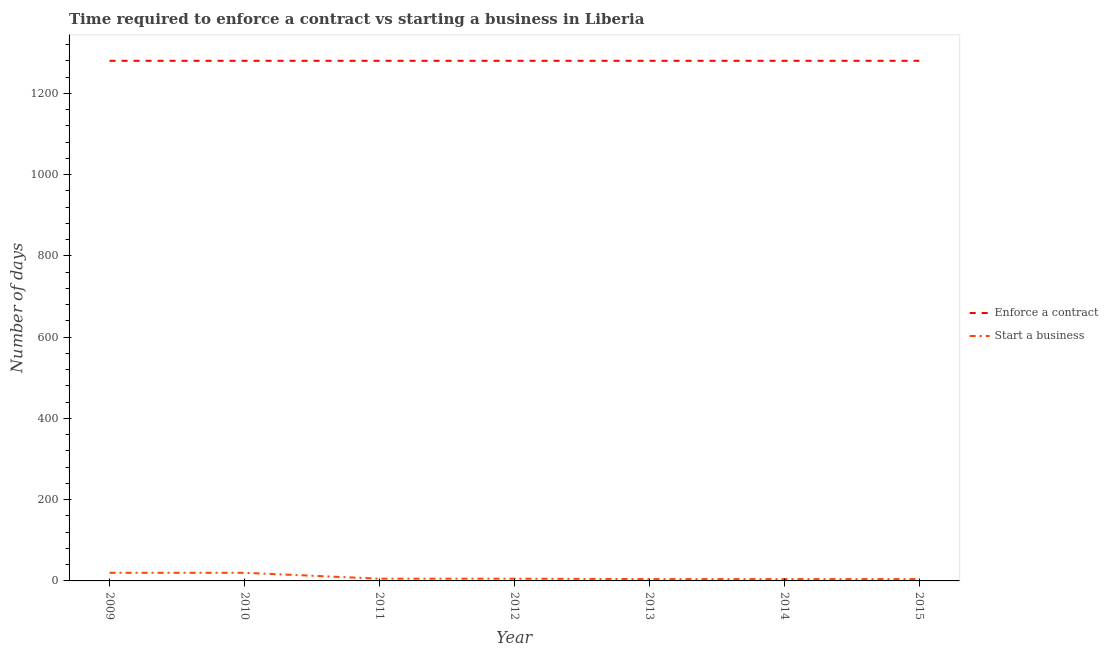How many different coloured lines are there?
Keep it short and to the point. 2. Does the line corresponding to number of days to start a business intersect with the line corresponding to number of days to enforece a contract?
Ensure brevity in your answer.  No. Across all years, what is the maximum number of days to enforece a contract?
Offer a terse response. 1280. What is the total number of days to start a business in the graph?
Provide a short and direct response. 64.5. What is the difference between the number of days to enforece a contract in 2015 and the number of days to start a business in 2012?
Ensure brevity in your answer.  1274.5. What is the average number of days to enforece a contract per year?
Ensure brevity in your answer.  1280. In the year 2010, what is the difference between the number of days to enforece a contract and number of days to start a business?
Offer a terse response. 1260. In how many years, is the number of days to enforece a contract greater than 200 days?
Ensure brevity in your answer.  7. Is the difference between the number of days to enforece a contract in 2010 and 2014 greater than the difference between the number of days to start a business in 2010 and 2014?
Your answer should be very brief. No. What is the difference between the highest and the second highest number of days to enforece a contract?
Provide a succinct answer. 0. In how many years, is the number of days to enforece a contract greater than the average number of days to enforece a contract taken over all years?
Your response must be concise. 0. Is the sum of the number of days to start a business in 2009 and 2012 greater than the maximum number of days to enforece a contract across all years?
Your answer should be compact. No. Does the number of days to start a business monotonically increase over the years?
Provide a succinct answer. No. How many lines are there?
Your answer should be compact. 2. What is the difference between two consecutive major ticks on the Y-axis?
Your answer should be very brief. 200. Does the graph contain any zero values?
Provide a succinct answer. No. Where does the legend appear in the graph?
Offer a terse response. Center right. What is the title of the graph?
Provide a short and direct response. Time required to enforce a contract vs starting a business in Liberia. What is the label or title of the Y-axis?
Provide a short and direct response. Number of days. What is the Number of days in Enforce a contract in 2009?
Give a very brief answer. 1280. What is the Number of days of Enforce a contract in 2010?
Provide a short and direct response. 1280. What is the Number of days of Start a business in 2010?
Provide a succinct answer. 20. What is the Number of days of Enforce a contract in 2011?
Provide a succinct answer. 1280. What is the Number of days in Start a business in 2011?
Offer a very short reply. 5.5. What is the Number of days in Enforce a contract in 2012?
Offer a terse response. 1280. What is the Number of days of Enforce a contract in 2013?
Provide a succinct answer. 1280. What is the Number of days in Enforce a contract in 2014?
Make the answer very short. 1280. What is the Number of days of Enforce a contract in 2015?
Your response must be concise. 1280. Across all years, what is the maximum Number of days of Enforce a contract?
Provide a short and direct response. 1280. Across all years, what is the maximum Number of days of Start a business?
Your answer should be compact. 20. Across all years, what is the minimum Number of days of Enforce a contract?
Your answer should be very brief. 1280. What is the total Number of days of Enforce a contract in the graph?
Your answer should be compact. 8960. What is the total Number of days of Start a business in the graph?
Provide a short and direct response. 64.5. What is the difference between the Number of days in Start a business in 2009 and that in 2010?
Your answer should be compact. 0. What is the difference between the Number of days of Start a business in 2009 and that in 2011?
Keep it short and to the point. 14.5. What is the difference between the Number of days of Enforce a contract in 2009 and that in 2013?
Keep it short and to the point. 0. What is the difference between the Number of days in Start a business in 2009 and that in 2013?
Provide a succinct answer. 15.5. What is the difference between the Number of days of Enforce a contract in 2009 and that in 2014?
Offer a terse response. 0. What is the difference between the Number of days of Start a business in 2009 and that in 2014?
Provide a short and direct response. 15.5. What is the difference between the Number of days of Start a business in 2009 and that in 2015?
Give a very brief answer. 15.5. What is the difference between the Number of days of Enforce a contract in 2010 and that in 2012?
Your response must be concise. 0. What is the difference between the Number of days of Enforce a contract in 2010 and that in 2013?
Ensure brevity in your answer.  0. What is the difference between the Number of days in Start a business in 2010 and that in 2014?
Offer a very short reply. 15.5. What is the difference between the Number of days of Start a business in 2010 and that in 2015?
Your response must be concise. 15.5. What is the difference between the Number of days in Enforce a contract in 2011 and that in 2012?
Provide a short and direct response. 0. What is the difference between the Number of days of Enforce a contract in 2011 and that in 2013?
Ensure brevity in your answer.  0. What is the difference between the Number of days of Enforce a contract in 2011 and that in 2014?
Provide a short and direct response. 0. What is the difference between the Number of days of Start a business in 2011 and that in 2014?
Your answer should be very brief. 1. What is the difference between the Number of days of Enforce a contract in 2011 and that in 2015?
Keep it short and to the point. 0. What is the difference between the Number of days in Start a business in 2011 and that in 2015?
Your answer should be very brief. 1. What is the difference between the Number of days of Enforce a contract in 2012 and that in 2013?
Your response must be concise. 0. What is the difference between the Number of days in Start a business in 2012 and that in 2013?
Offer a terse response. 1. What is the difference between the Number of days in Enforce a contract in 2012 and that in 2014?
Give a very brief answer. 0. What is the difference between the Number of days of Start a business in 2012 and that in 2014?
Your answer should be compact. 1. What is the difference between the Number of days in Enforce a contract in 2013 and that in 2014?
Your answer should be compact. 0. What is the difference between the Number of days in Start a business in 2013 and that in 2014?
Your answer should be very brief. 0. What is the difference between the Number of days of Enforce a contract in 2013 and that in 2015?
Give a very brief answer. 0. What is the difference between the Number of days in Start a business in 2013 and that in 2015?
Your response must be concise. 0. What is the difference between the Number of days of Enforce a contract in 2014 and that in 2015?
Your answer should be very brief. 0. What is the difference between the Number of days in Enforce a contract in 2009 and the Number of days in Start a business in 2010?
Your answer should be compact. 1260. What is the difference between the Number of days of Enforce a contract in 2009 and the Number of days of Start a business in 2011?
Make the answer very short. 1274.5. What is the difference between the Number of days in Enforce a contract in 2009 and the Number of days in Start a business in 2012?
Keep it short and to the point. 1274.5. What is the difference between the Number of days of Enforce a contract in 2009 and the Number of days of Start a business in 2013?
Your answer should be very brief. 1275.5. What is the difference between the Number of days of Enforce a contract in 2009 and the Number of days of Start a business in 2014?
Offer a terse response. 1275.5. What is the difference between the Number of days of Enforce a contract in 2009 and the Number of days of Start a business in 2015?
Your answer should be compact. 1275.5. What is the difference between the Number of days in Enforce a contract in 2010 and the Number of days in Start a business in 2011?
Keep it short and to the point. 1274.5. What is the difference between the Number of days of Enforce a contract in 2010 and the Number of days of Start a business in 2012?
Make the answer very short. 1274.5. What is the difference between the Number of days of Enforce a contract in 2010 and the Number of days of Start a business in 2013?
Give a very brief answer. 1275.5. What is the difference between the Number of days of Enforce a contract in 2010 and the Number of days of Start a business in 2014?
Your response must be concise. 1275.5. What is the difference between the Number of days in Enforce a contract in 2010 and the Number of days in Start a business in 2015?
Provide a succinct answer. 1275.5. What is the difference between the Number of days in Enforce a contract in 2011 and the Number of days in Start a business in 2012?
Ensure brevity in your answer.  1274.5. What is the difference between the Number of days of Enforce a contract in 2011 and the Number of days of Start a business in 2013?
Offer a terse response. 1275.5. What is the difference between the Number of days of Enforce a contract in 2011 and the Number of days of Start a business in 2014?
Ensure brevity in your answer.  1275.5. What is the difference between the Number of days in Enforce a contract in 2011 and the Number of days in Start a business in 2015?
Give a very brief answer. 1275.5. What is the difference between the Number of days in Enforce a contract in 2012 and the Number of days in Start a business in 2013?
Make the answer very short. 1275.5. What is the difference between the Number of days of Enforce a contract in 2012 and the Number of days of Start a business in 2014?
Give a very brief answer. 1275.5. What is the difference between the Number of days in Enforce a contract in 2012 and the Number of days in Start a business in 2015?
Keep it short and to the point. 1275.5. What is the difference between the Number of days of Enforce a contract in 2013 and the Number of days of Start a business in 2014?
Keep it short and to the point. 1275.5. What is the difference between the Number of days of Enforce a contract in 2013 and the Number of days of Start a business in 2015?
Keep it short and to the point. 1275.5. What is the difference between the Number of days in Enforce a contract in 2014 and the Number of days in Start a business in 2015?
Your answer should be very brief. 1275.5. What is the average Number of days in Enforce a contract per year?
Ensure brevity in your answer.  1280. What is the average Number of days of Start a business per year?
Your response must be concise. 9.21. In the year 2009, what is the difference between the Number of days of Enforce a contract and Number of days of Start a business?
Keep it short and to the point. 1260. In the year 2010, what is the difference between the Number of days of Enforce a contract and Number of days of Start a business?
Offer a very short reply. 1260. In the year 2011, what is the difference between the Number of days in Enforce a contract and Number of days in Start a business?
Provide a succinct answer. 1274.5. In the year 2012, what is the difference between the Number of days in Enforce a contract and Number of days in Start a business?
Make the answer very short. 1274.5. In the year 2013, what is the difference between the Number of days in Enforce a contract and Number of days in Start a business?
Offer a terse response. 1275.5. In the year 2014, what is the difference between the Number of days of Enforce a contract and Number of days of Start a business?
Give a very brief answer. 1275.5. In the year 2015, what is the difference between the Number of days of Enforce a contract and Number of days of Start a business?
Your answer should be compact. 1275.5. What is the ratio of the Number of days of Start a business in 2009 to that in 2010?
Your response must be concise. 1. What is the ratio of the Number of days in Start a business in 2009 to that in 2011?
Offer a very short reply. 3.64. What is the ratio of the Number of days of Enforce a contract in 2009 to that in 2012?
Keep it short and to the point. 1. What is the ratio of the Number of days of Start a business in 2009 to that in 2012?
Offer a terse response. 3.64. What is the ratio of the Number of days of Enforce a contract in 2009 to that in 2013?
Offer a terse response. 1. What is the ratio of the Number of days in Start a business in 2009 to that in 2013?
Provide a succinct answer. 4.44. What is the ratio of the Number of days in Start a business in 2009 to that in 2014?
Keep it short and to the point. 4.44. What is the ratio of the Number of days of Start a business in 2009 to that in 2015?
Ensure brevity in your answer.  4.44. What is the ratio of the Number of days of Enforce a contract in 2010 to that in 2011?
Give a very brief answer. 1. What is the ratio of the Number of days in Start a business in 2010 to that in 2011?
Provide a succinct answer. 3.64. What is the ratio of the Number of days in Start a business in 2010 to that in 2012?
Ensure brevity in your answer.  3.64. What is the ratio of the Number of days of Enforce a contract in 2010 to that in 2013?
Keep it short and to the point. 1. What is the ratio of the Number of days of Start a business in 2010 to that in 2013?
Your answer should be very brief. 4.44. What is the ratio of the Number of days in Enforce a contract in 2010 to that in 2014?
Offer a very short reply. 1. What is the ratio of the Number of days of Start a business in 2010 to that in 2014?
Give a very brief answer. 4.44. What is the ratio of the Number of days in Enforce a contract in 2010 to that in 2015?
Keep it short and to the point. 1. What is the ratio of the Number of days in Start a business in 2010 to that in 2015?
Your answer should be very brief. 4.44. What is the ratio of the Number of days in Enforce a contract in 2011 to that in 2012?
Provide a short and direct response. 1. What is the ratio of the Number of days in Start a business in 2011 to that in 2012?
Your response must be concise. 1. What is the ratio of the Number of days in Start a business in 2011 to that in 2013?
Your response must be concise. 1.22. What is the ratio of the Number of days of Enforce a contract in 2011 to that in 2014?
Your answer should be compact. 1. What is the ratio of the Number of days of Start a business in 2011 to that in 2014?
Keep it short and to the point. 1.22. What is the ratio of the Number of days of Start a business in 2011 to that in 2015?
Your response must be concise. 1.22. What is the ratio of the Number of days of Start a business in 2012 to that in 2013?
Your answer should be very brief. 1.22. What is the ratio of the Number of days in Start a business in 2012 to that in 2014?
Your answer should be very brief. 1.22. What is the ratio of the Number of days in Start a business in 2012 to that in 2015?
Provide a succinct answer. 1.22. What is the ratio of the Number of days of Enforce a contract in 2013 to that in 2014?
Make the answer very short. 1. What is the ratio of the Number of days in Start a business in 2014 to that in 2015?
Offer a terse response. 1. What is the difference between the highest and the lowest Number of days in Enforce a contract?
Offer a terse response. 0. 